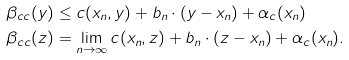<formula> <loc_0><loc_0><loc_500><loc_500>\beta _ { c c } ( y ) & \leq c ( x _ { n } , y ) + b _ { n } \cdot ( y - x _ { n } ) + \alpha _ { c } ( x _ { n } ) \\ \beta _ { c c } ( z ) & = \lim _ { n \to \infty } c ( x _ { n } , z ) + b _ { n } \cdot ( z - x _ { n } ) + \alpha _ { c } ( x _ { n } ) .</formula> 